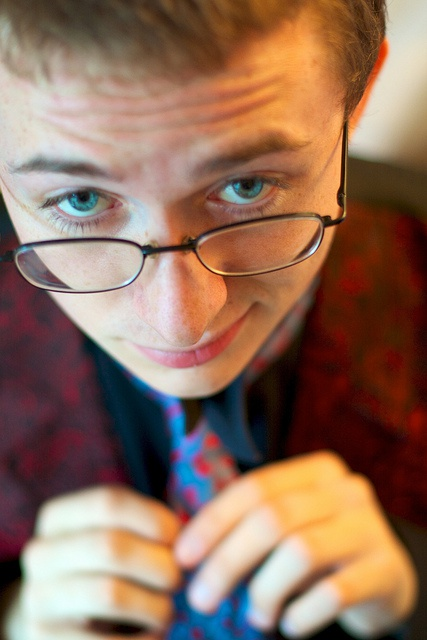Describe the objects in this image and their specific colors. I can see people in maroon, black, lightgray, and orange tones and tie in maroon, black, navy, blue, and brown tones in this image. 